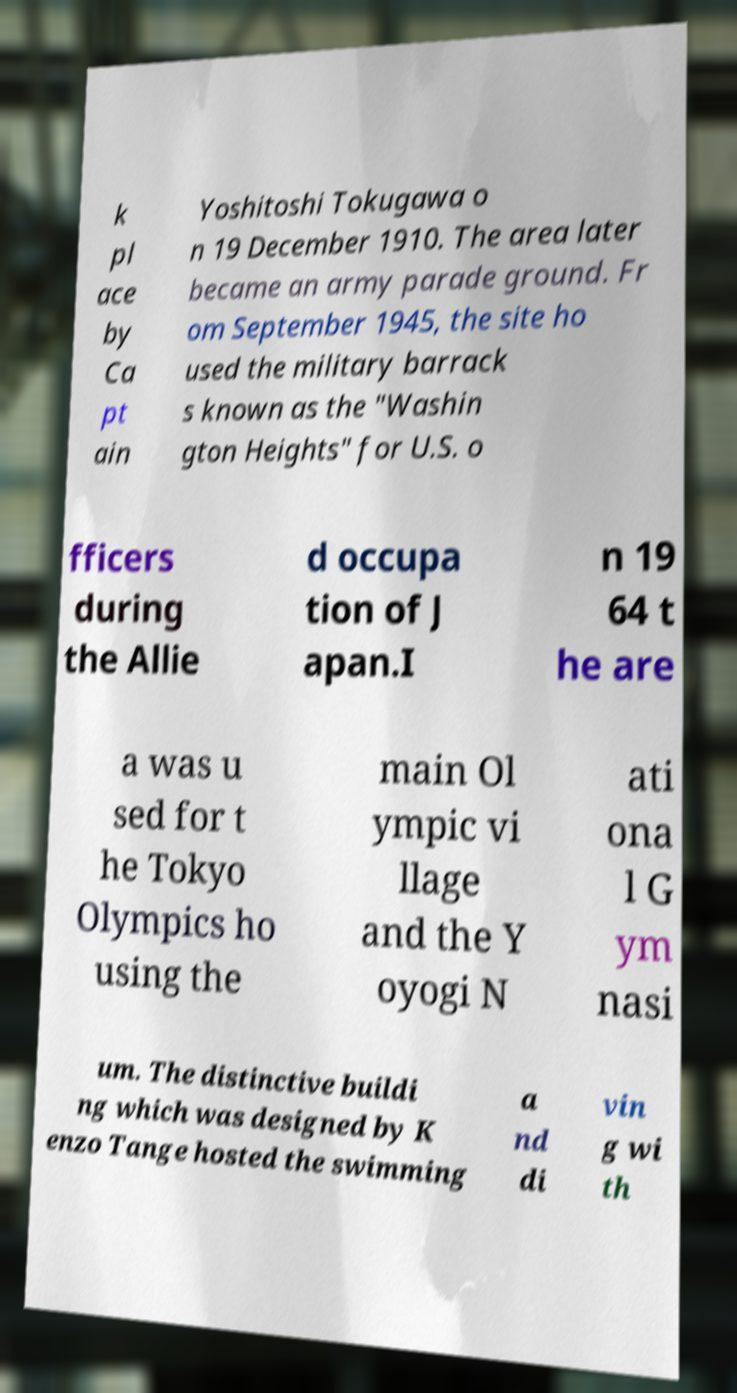Please read and relay the text visible in this image. What does it say? k pl ace by Ca pt ain Yoshitoshi Tokugawa o n 19 December 1910. The area later became an army parade ground. Fr om September 1945, the site ho used the military barrack s known as the "Washin gton Heights" for U.S. o fficers during the Allie d occupa tion of J apan.I n 19 64 t he are a was u sed for t he Tokyo Olympics ho using the main Ol ympic vi llage and the Y oyogi N ati ona l G ym nasi um. The distinctive buildi ng which was designed by K enzo Tange hosted the swimming a nd di vin g wi th 